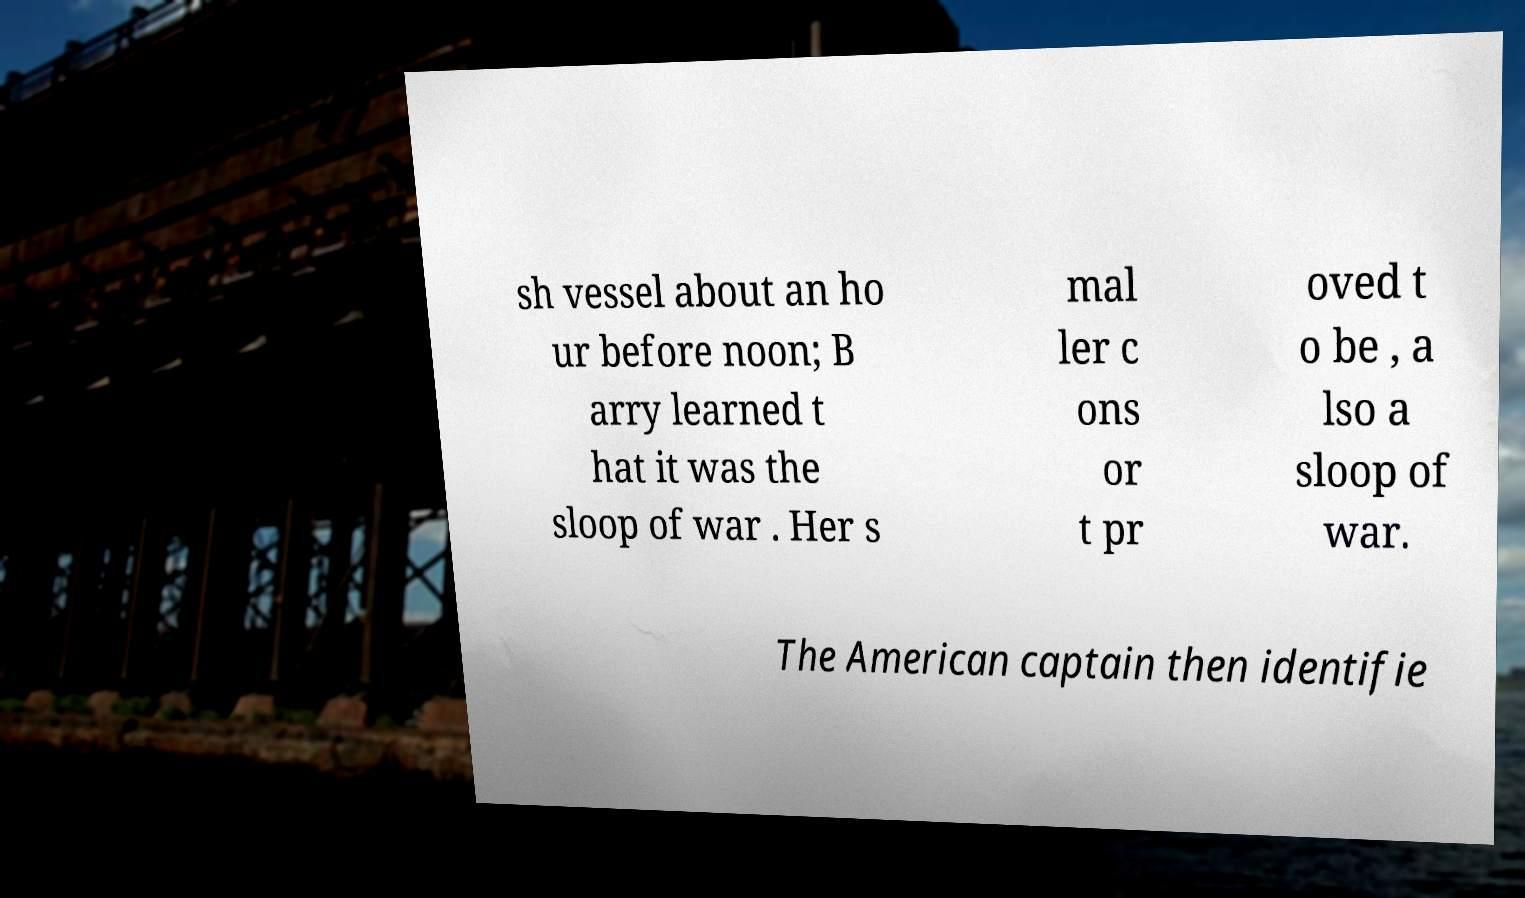What messages or text are displayed in this image? I need them in a readable, typed format. sh vessel about an ho ur before noon; B arry learned t hat it was the sloop of war . Her s mal ler c ons or t pr oved t o be , a lso a sloop of war. The American captain then identifie 